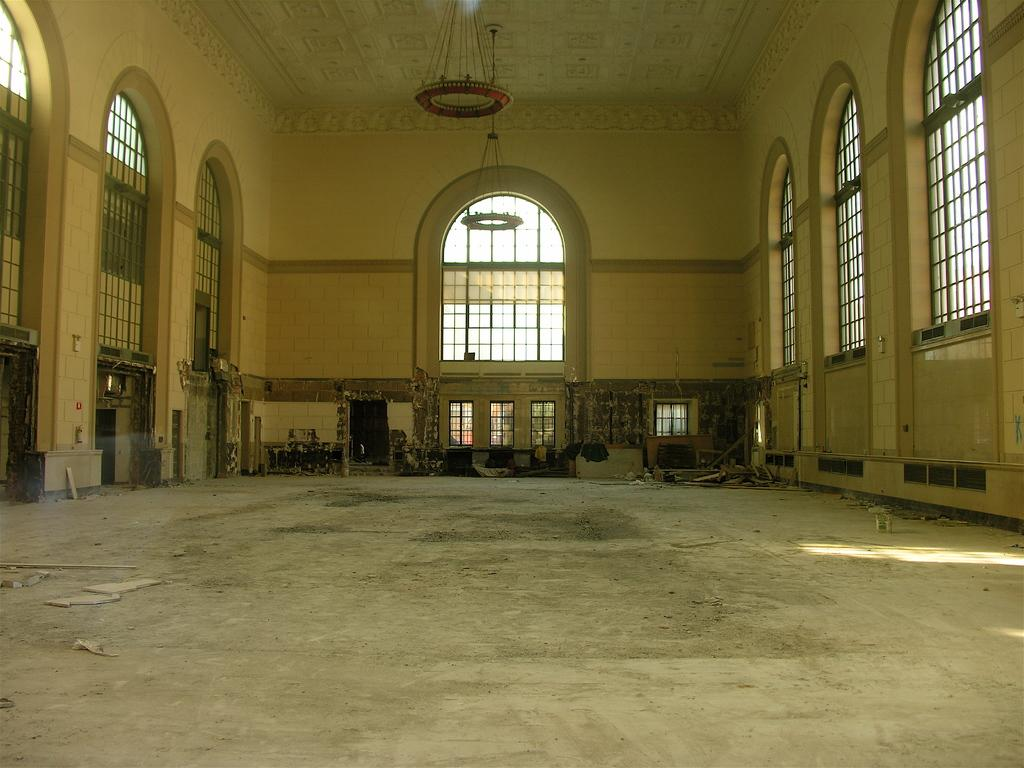What is the setting of the image? The image depicts the inside of a room. Can you describe any specific features of the room? There are multiple windows visible on the wall. What statement does the range make about the breath in the image? There is no range or breath present in the image, as it depicts the inside of a room with multiple windows. 